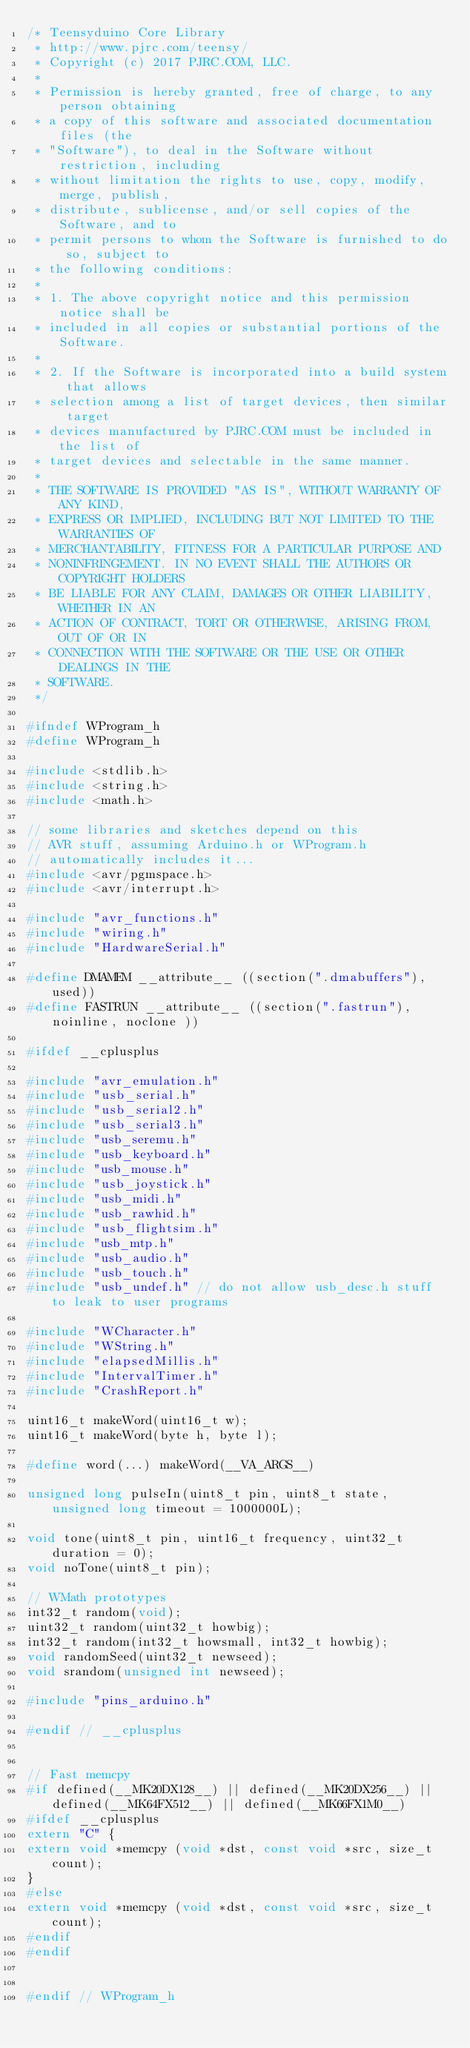<code> <loc_0><loc_0><loc_500><loc_500><_C_>/* Teensyduino Core Library
 * http://www.pjrc.com/teensy/
 * Copyright (c) 2017 PJRC.COM, LLC.
 *
 * Permission is hereby granted, free of charge, to any person obtaining
 * a copy of this software and associated documentation files (the
 * "Software"), to deal in the Software without restriction, including
 * without limitation the rights to use, copy, modify, merge, publish,
 * distribute, sublicense, and/or sell copies of the Software, and to
 * permit persons to whom the Software is furnished to do so, subject to
 * the following conditions:
 *
 * 1. The above copyright notice and this permission notice shall be
 * included in all copies or substantial portions of the Software.
 *
 * 2. If the Software is incorporated into a build system that allows
 * selection among a list of target devices, then similar target
 * devices manufactured by PJRC.COM must be included in the list of
 * target devices and selectable in the same manner.
 *
 * THE SOFTWARE IS PROVIDED "AS IS", WITHOUT WARRANTY OF ANY KIND,
 * EXPRESS OR IMPLIED, INCLUDING BUT NOT LIMITED TO THE WARRANTIES OF
 * MERCHANTABILITY, FITNESS FOR A PARTICULAR PURPOSE AND
 * NONINFRINGEMENT. IN NO EVENT SHALL THE AUTHORS OR COPYRIGHT HOLDERS
 * BE LIABLE FOR ANY CLAIM, DAMAGES OR OTHER LIABILITY, WHETHER IN AN
 * ACTION OF CONTRACT, TORT OR OTHERWISE, ARISING FROM, OUT OF OR IN
 * CONNECTION WITH THE SOFTWARE OR THE USE OR OTHER DEALINGS IN THE
 * SOFTWARE.
 */

#ifndef WProgram_h
#define WProgram_h

#include <stdlib.h>
#include <string.h>
#include <math.h>

// some libraries and sketches depend on this
// AVR stuff, assuming Arduino.h or WProgram.h
// automatically includes it...
#include <avr/pgmspace.h>
#include <avr/interrupt.h>

#include "avr_functions.h"
#include "wiring.h"
#include "HardwareSerial.h"

#define DMAMEM __attribute__ ((section(".dmabuffers"), used))
#define FASTRUN __attribute__ ((section(".fastrun"), noinline, noclone ))

#ifdef __cplusplus

#include "avr_emulation.h"
#include "usb_serial.h"
#include "usb_serial2.h"
#include "usb_serial3.h"
#include "usb_seremu.h"
#include "usb_keyboard.h"
#include "usb_mouse.h"
#include "usb_joystick.h"
#include "usb_midi.h"
#include "usb_rawhid.h"
#include "usb_flightsim.h"
#include "usb_mtp.h"
#include "usb_audio.h"
#include "usb_touch.h"
#include "usb_undef.h" // do not allow usb_desc.h stuff to leak to user programs

#include "WCharacter.h"
#include "WString.h"
#include "elapsedMillis.h"
#include "IntervalTimer.h"
#include "CrashReport.h"

uint16_t makeWord(uint16_t w);
uint16_t makeWord(byte h, byte l);

#define word(...) makeWord(__VA_ARGS__)

unsigned long pulseIn(uint8_t pin, uint8_t state, unsigned long timeout = 1000000L);

void tone(uint8_t pin, uint16_t frequency, uint32_t duration = 0);
void noTone(uint8_t pin);

// WMath prototypes
int32_t random(void);
uint32_t random(uint32_t howbig);
int32_t random(int32_t howsmall, int32_t howbig);
void randomSeed(uint32_t newseed);
void srandom(unsigned int newseed);

#include "pins_arduino.h"

#endif // __cplusplus


// Fast memcpy
#if defined(__MK20DX128__) || defined(__MK20DX256__) || defined(__MK64FX512__) || defined(__MK66FX1M0__)
#ifdef __cplusplus
extern "C" {
extern void *memcpy (void *dst, const void *src, size_t count);
}
#else
extern void *memcpy (void *dst, const void *src, size_t count);
#endif
#endif


#endif // WProgram_h
</code> 